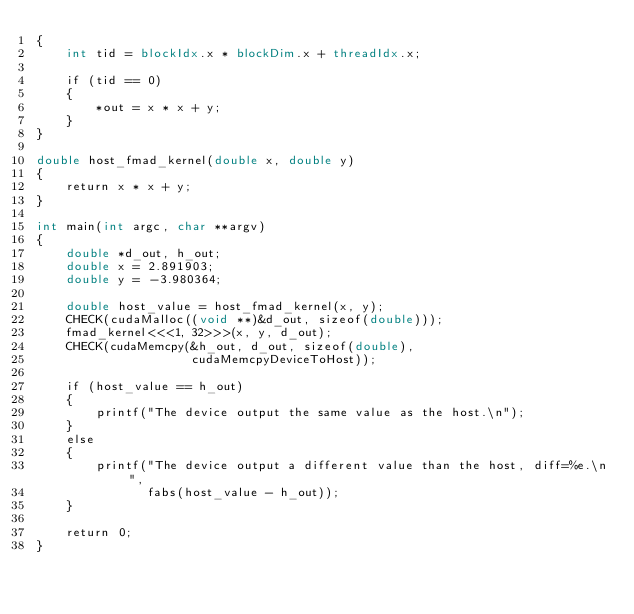Convert code to text. <code><loc_0><loc_0><loc_500><loc_500><_Cuda_>{
    int tid = blockIdx.x * blockDim.x + threadIdx.x;

    if (tid == 0)
    {
        *out = x * x + y;
    }
}

double host_fmad_kernel(double x, double y)
{
    return x * x + y;
}

int main(int argc, char **argv)
{
    double *d_out, h_out;
    double x = 2.891903;
    double y = -3.980364;

    double host_value = host_fmad_kernel(x, y);
    CHECK(cudaMalloc((void **)&d_out, sizeof(double)));
    fmad_kernel<<<1, 32>>>(x, y, d_out);
    CHECK(cudaMemcpy(&h_out, d_out, sizeof(double),
                     cudaMemcpyDeviceToHost));

    if (host_value == h_out)
    {
        printf("The device output the same value as the host.\n");
    }
    else
    {
        printf("The device output a different value than the host, diff=%e.\n",
               fabs(host_value - h_out));
    }

    return 0;
}
</code> 